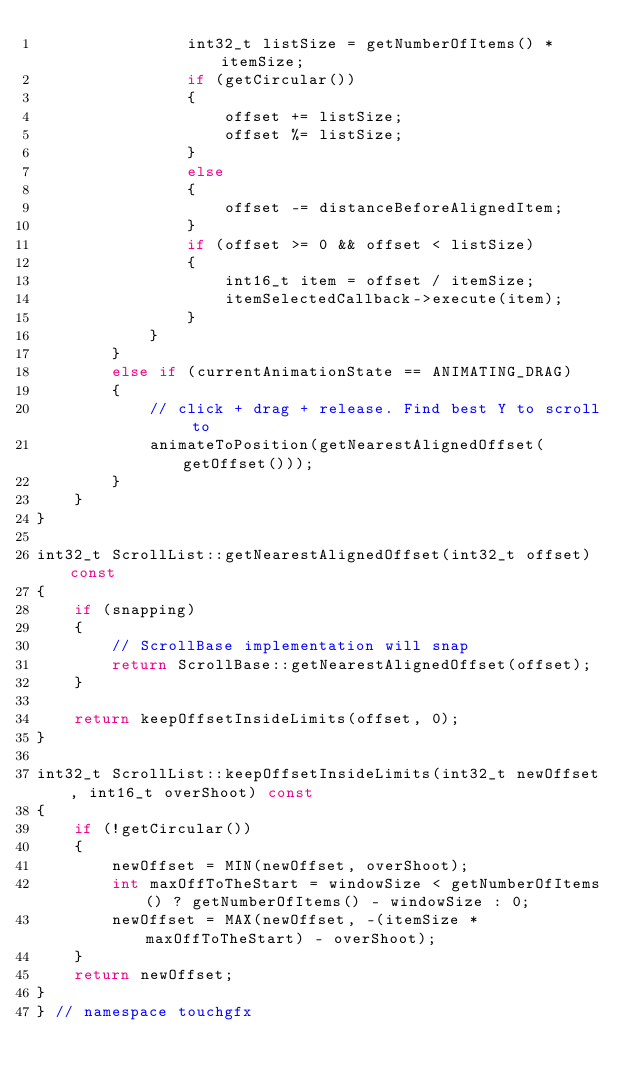<code> <loc_0><loc_0><loc_500><loc_500><_C++_>                int32_t listSize = getNumberOfItems() * itemSize;
                if (getCircular())
                {
                    offset += listSize;
                    offset %= listSize;
                }
                else
                {
                    offset -= distanceBeforeAlignedItem;
                }
                if (offset >= 0 && offset < listSize)
                {
                    int16_t item = offset / itemSize;
                    itemSelectedCallback->execute(item);
                }
            }
        }
        else if (currentAnimationState == ANIMATING_DRAG)
        {
            // click + drag + release. Find best Y to scroll to
            animateToPosition(getNearestAlignedOffset(getOffset()));
        }
    }
}

int32_t ScrollList::getNearestAlignedOffset(int32_t offset) const
{
    if (snapping)
    {
        // ScrollBase implementation will snap
        return ScrollBase::getNearestAlignedOffset(offset);
    }

    return keepOffsetInsideLimits(offset, 0);
}

int32_t ScrollList::keepOffsetInsideLimits(int32_t newOffset, int16_t overShoot) const
{
    if (!getCircular())
    {
        newOffset = MIN(newOffset, overShoot);
        int maxOffToTheStart = windowSize < getNumberOfItems() ? getNumberOfItems() - windowSize : 0;
        newOffset = MAX(newOffset, -(itemSize * maxOffToTheStart) - overShoot);
    }
    return newOffset;
}
} // namespace touchgfx
</code> 